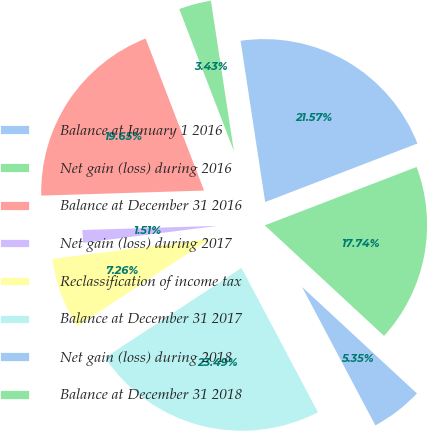Convert chart. <chart><loc_0><loc_0><loc_500><loc_500><pie_chart><fcel>Balance at January 1 2016<fcel>Net gain (loss) during 2016<fcel>Balance at December 31 2016<fcel>Net gain (loss) during 2017<fcel>Reclassification of income tax<fcel>Balance at December 31 2017<fcel>Net gain (loss) during 2018<fcel>Balance at December 31 2018<nl><fcel>21.57%<fcel>3.43%<fcel>19.65%<fcel>1.51%<fcel>7.26%<fcel>23.49%<fcel>5.35%<fcel>17.74%<nl></chart> 